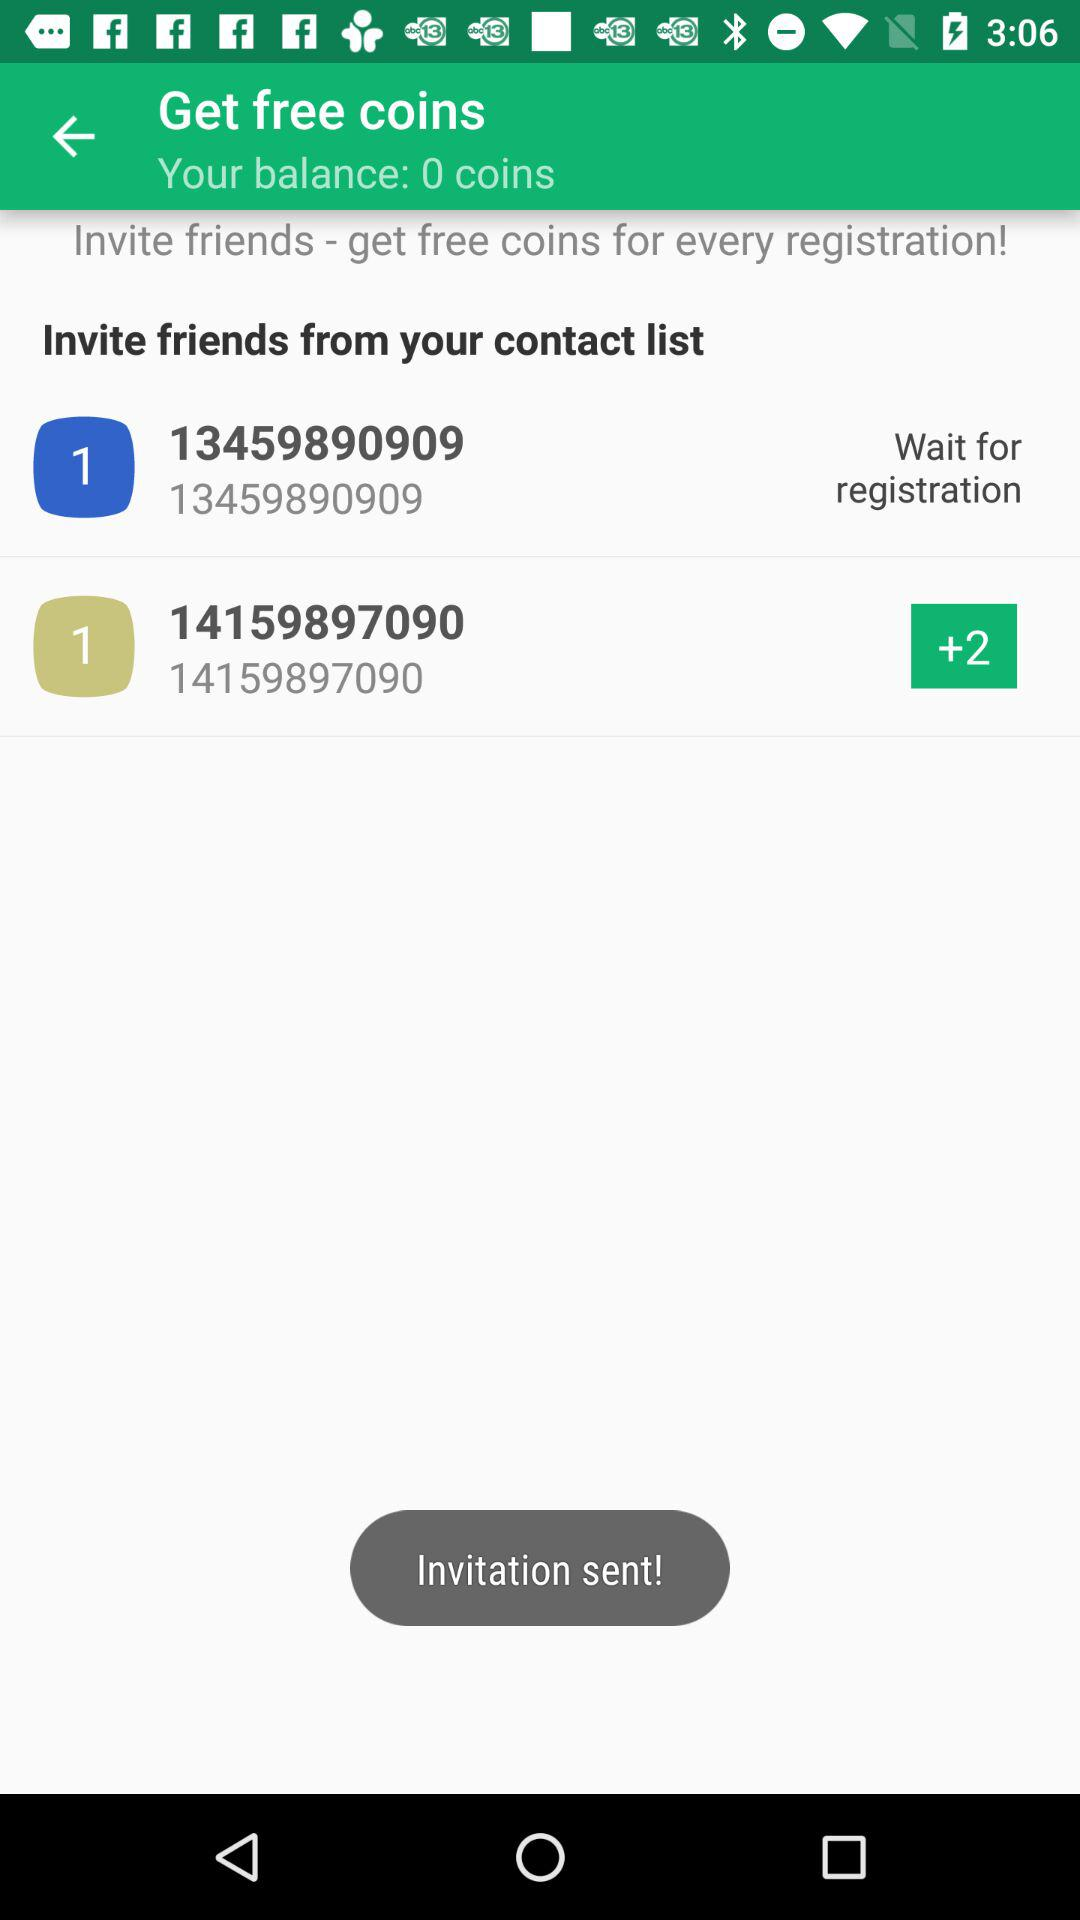How many coins are there in the balance? There are 0 coins in the balance. 